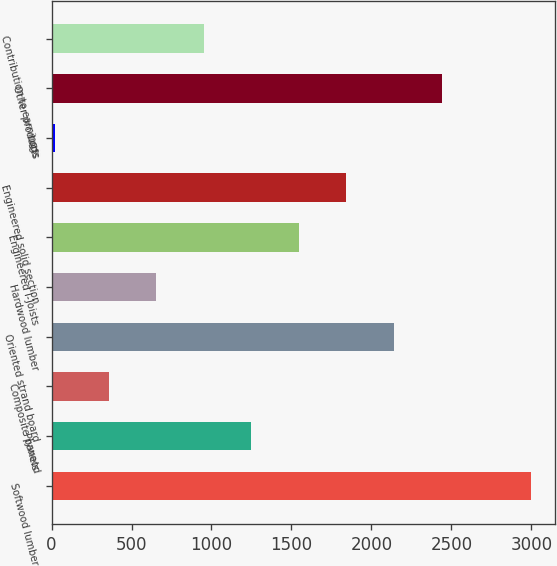Convert chart to OTSL. <chart><loc_0><loc_0><loc_500><loc_500><bar_chart><fcel>Softwood lumber<fcel>Plywood<fcel>Composite panels<fcel>Oriented strand board<fcel>Hardwood lumber<fcel>Engineered I-Joists<fcel>Engineered solid section<fcel>Logs<fcel>Other products<fcel>Contribution to earnings<nl><fcel>2997<fcel>1249.2<fcel>357<fcel>2141.4<fcel>654.4<fcel>1546.6<fcel>1844<fcel>23<fcel>2438.8<fcel>951.8<nl></chart> 